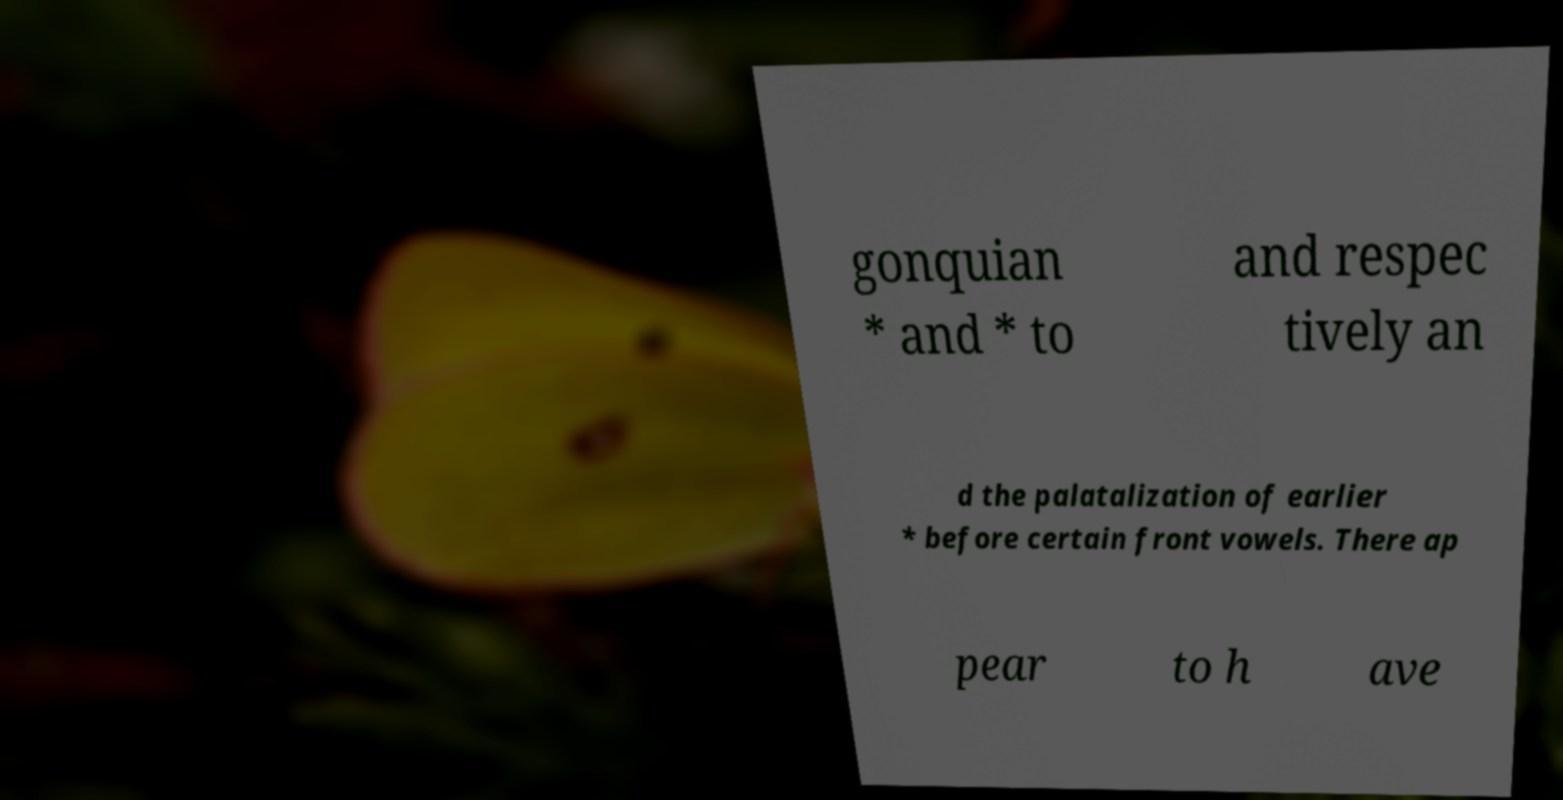Could you assist in decoding the text presented in this image and type it out clearly? gonquian * and * to and respec tively an d the palatalization of earlier * before certain front vowels. There ap pear to h ave 